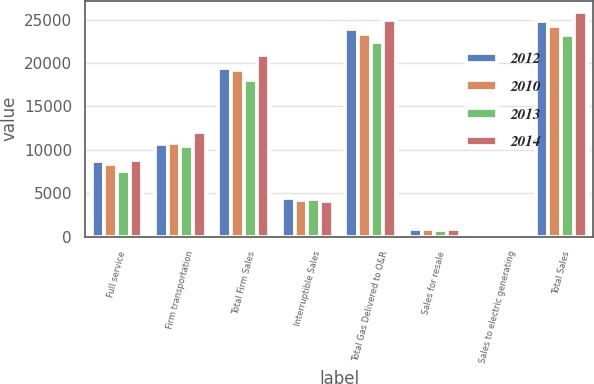Convert chart. <chart><loc_0><loc_0><loc_500><loc_500><stacked_bar_chart><ecel><fcel>Full service<fcel>Firm transportation<fcel>Total Firm Sales<fcel>Interruptible Sales<fcel>Total Gas Delivered to O&R<fcel>Sales for resale<fcel>Sales to electric generating<fcel>Total Sales<nl><fcel>2012<fcel>8772<fcel>10692<fcel>19464<fcel>4497<fcel>23961<fcel>840<fcel>19<fcel>24821<nl><fcel>2010<fcel>8384<fcel>10823<fcel>19207<fcel>4184<fcel>23391<fcel>864<fcel>24<fcel>24279<nl><fcel>2013<fcel>7539<fcel>10505<fcel>18044<fcel>4326<fcel>22370<fcel>793<fcel>15<fcel>23178<nl><fcel>2014<fcel>8808<fcel>12062<fcel>20870<fcel>4118<fcel>24988<fcel>885<fcel>19<fcel>25892<nl></chart> 